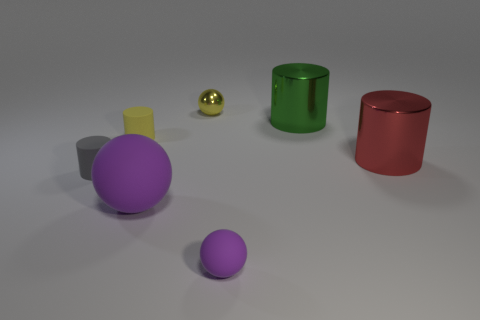Add 3 gray rubber cylinders. How many objects exist? 10 Subtract all cylinders. How many objects are left? 3 Subtract all tiny purple matte things. Subtract all small gray objects. How many objects are left? 5 Add 5 purple matte balls. How many purple matte balls are left? 7 Add 6 tiny yellow metal objects. How many tiny yellow metal objects exist? 7 Subtract 1 green cylinders. How many objects are left? 6 